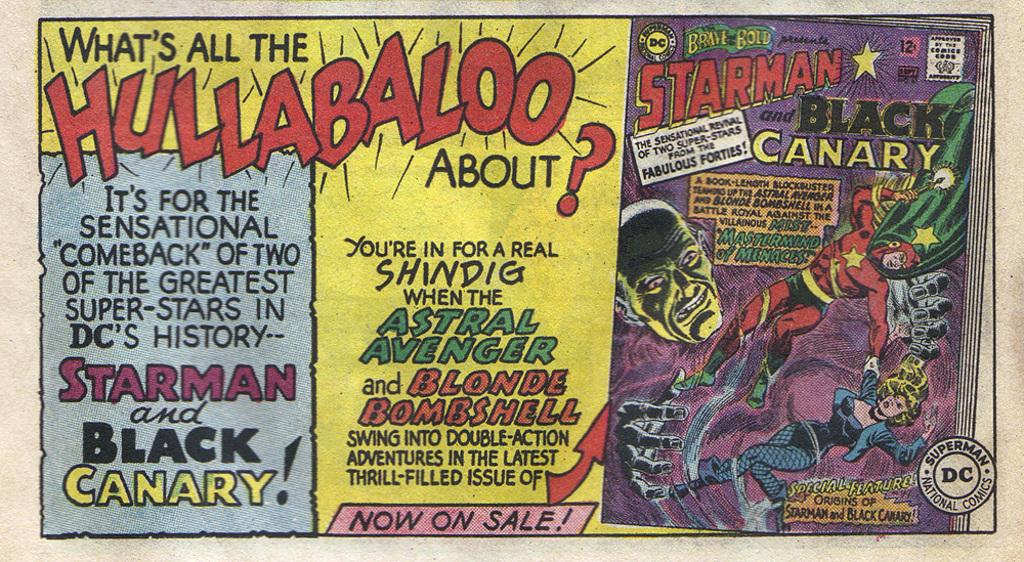Provide a one-sentence caption for the provided image. Three different comic books about the black canary. 